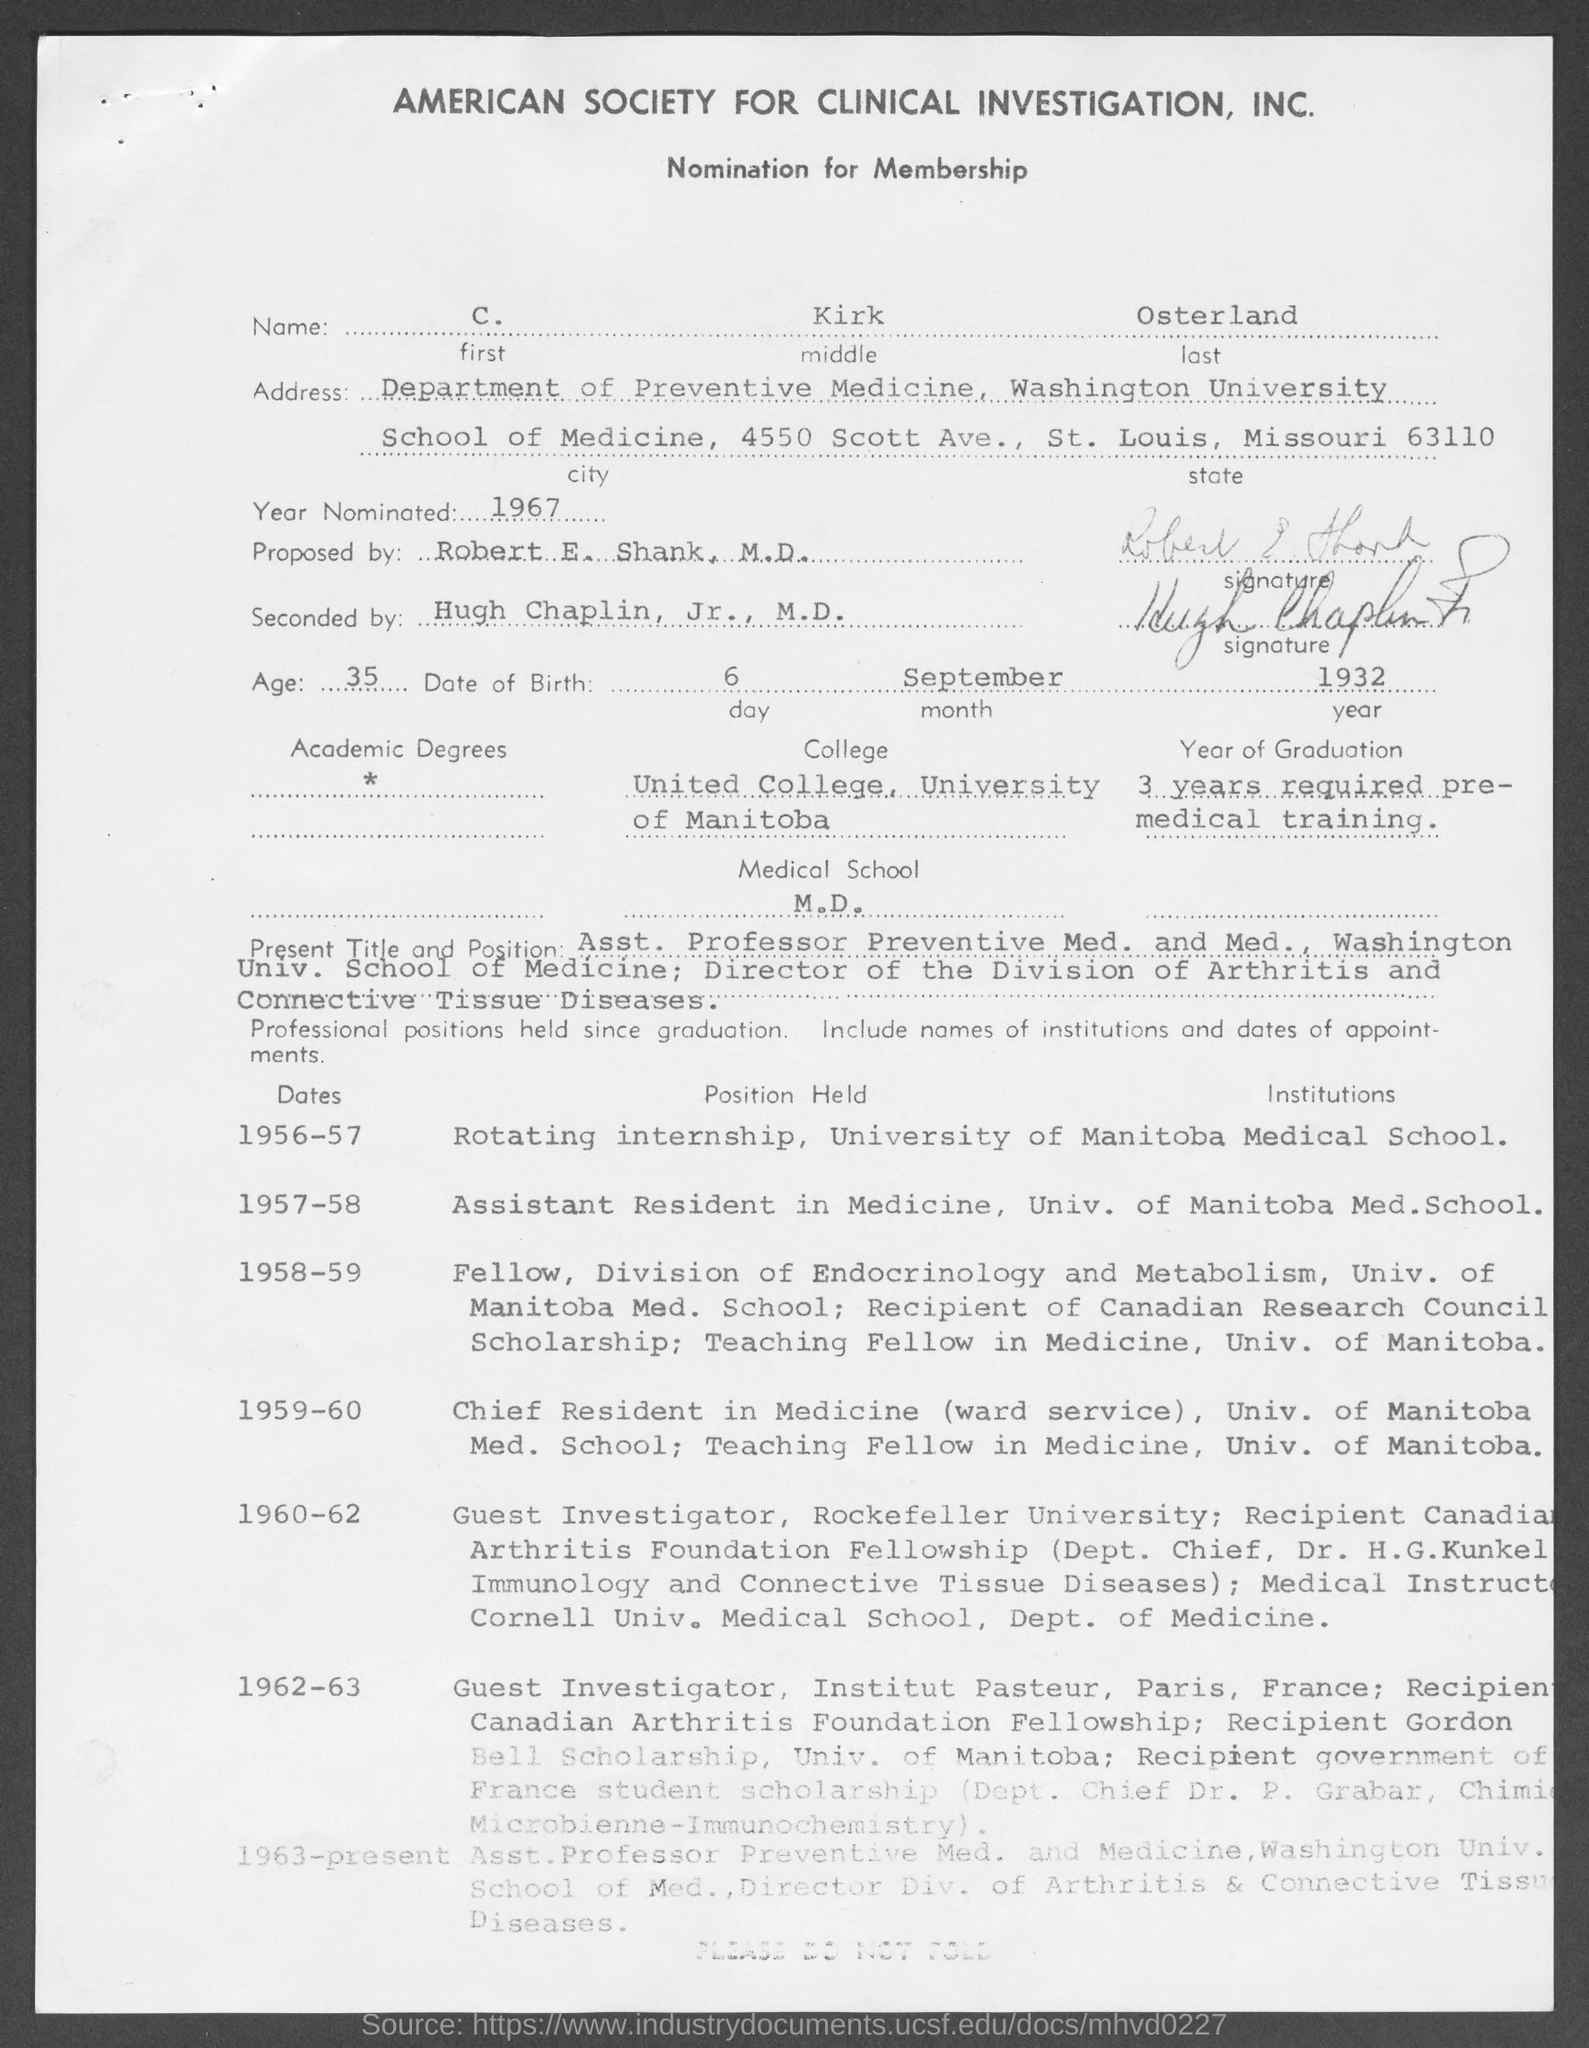What is the middle name mentioned in the given form ?
Your response must be concise. Kirk. What is the last name mentioned in the given form ?
Offer a very short reply. Osterland. What is the first name mentioned in the given form ?
Offer a terse response. C. What is the age mentioned in the given form ?
Give a very brief answer. 35. What is the year nominated as mentioned in the given form ?
Offer a terse response. 1967. What is the day mentioned in the date of birth in given form ?
Give a very brief answer. 6. What is the month mentioned in the date of birth in the given form ?
Ensure brevity in your answer.  September. What is the year mentioned in the date of birth in given form ?
Your answer should be compact. 1932. By whom this was proposed by as mentioned in the given form ?
Give a very brief answer. Robert E. Shank, M.D. 